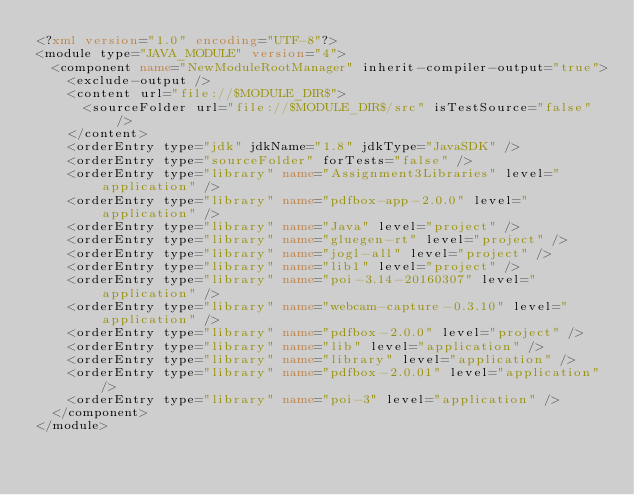Convert code to text. <code><loc_0><loc_0><loc_500><loc_500><_XML_><?xml version="1.0" encoding="UTF-8"?>
<module type="JAVA_MODULE" version="4">
  <component name="NewModuleRootManager" inherit-compiler-output="true">
    <exclude-output />
    <content url="file://$MODULE_DIR$">
      <sourceFolder url="file://$MODULE_DIR$/src" isTestSource="false" />
    </content>
    <orderEntry type="jdk" jdkName="1.8" jdkType="JavaSDK" />
    <orderEntry type="sourceFolder" forTests="false" />
    <orderEntry type="library" name="Assignment3Libraries" level="application" />
    <orderEntry type="library" name="pdfbox-app-2.0.0" level="application" />
    <orderEntry type="library" name="Java" level="project" />
    <orderEntry type="library" name="gluegen-rt" level="project" />
    <orderEntry type="library" name="jogl-all" level="project" />
    <orderEntry type="library" name="lib1" level="project" />
    <orderEntry type="library" name="poi-3.14-20160307" level="application" />
    <orderEntry type="library" name="webcam-capture-0.3.10" level="application" />
    <orderEntry type="library" name="pdfbox-2.0.0" level="project" />
    <orderEntry type="library" name="lib" level="application" />
    <orderEntry type="library" name="library" level="application" />
    <orderEntry type="library" name="pdfbox-2.0.01" level="application" />
    <orderEntry type="library" name="poi-3" level="application" />
  </component>
</module></code> 